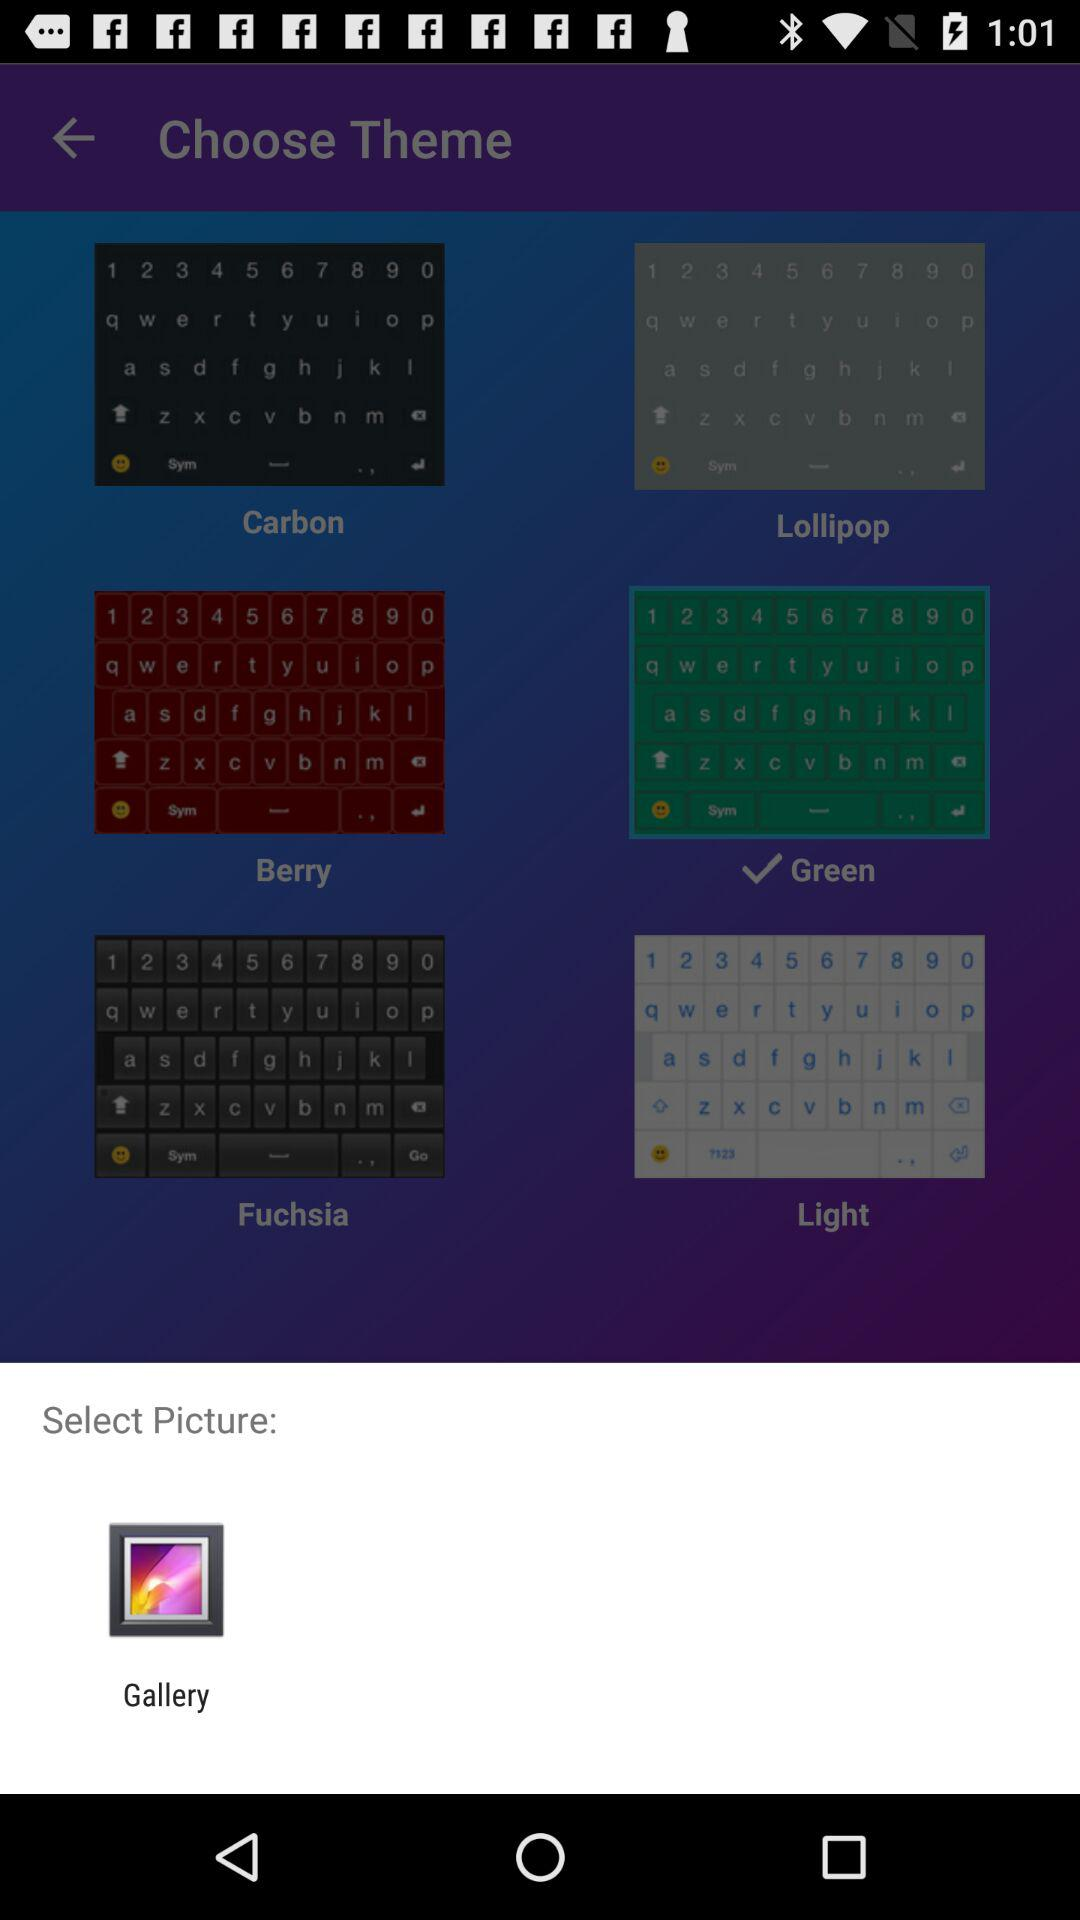Through what application can we select the picture? The application is Gallery. 